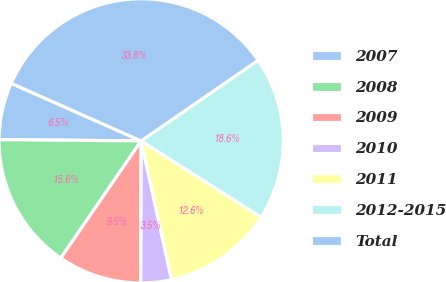Convert chart to OTSL. <chart><loc_0><loc_0><loc_500><loc_500><pie_chart><fcel>2007<fcel>2008<fcel>2009<fcel>2010<fcel>2011<fcel>2012-2015<fcel>Total<nl><fcel>6.5%<fcel>15.58%<fcel>9.53%<fcel>3.47%<fcel>12.56%<fcel>18.61%<fcel>33.76%<nl></chart> 